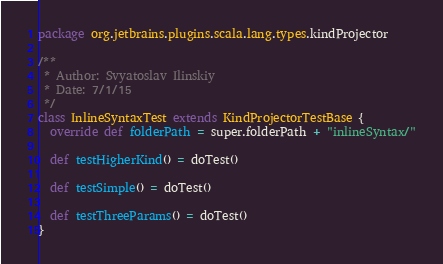Convert code to text. <code><loc_0><loc_0><loc_500><loc_500><_Scala_>package org.jetbrains.plugins.scala.lang.types.kindProjector

/**
 * Author: Svyatoslav Ilinskiy
 * Date: 7/1/15
 */
class InlineSyntaxTest extends KindProjectorTestBase {
  override def folderPath = super.folderPath + "inlineSyntax/"

  def testHigherKind() = doTest()

  def testSimple() = doTest()

  def testThreeParams() = doTest()
}
</code> 